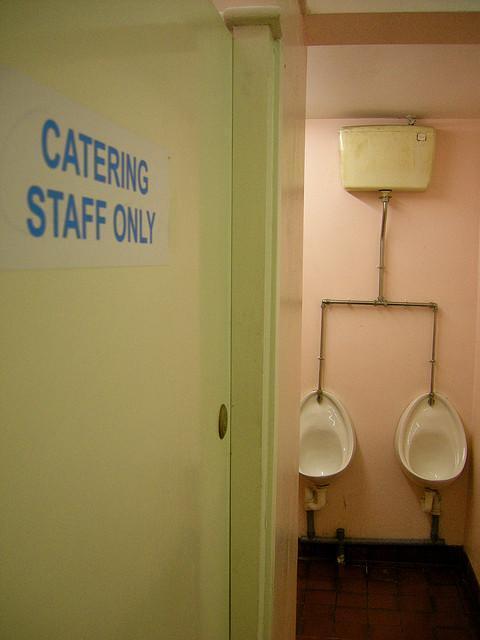How many bowls are in the picture?
Give a very brief answer. 2. How many screws are in the door?
Give a very brief answer. 0. How many toilets are in the bathroom?
Give a very brief answer. 2. How many toilets are there?
Give a very brief answer. 2. How many toilets can you see?
Give a very brief answer. 2. 